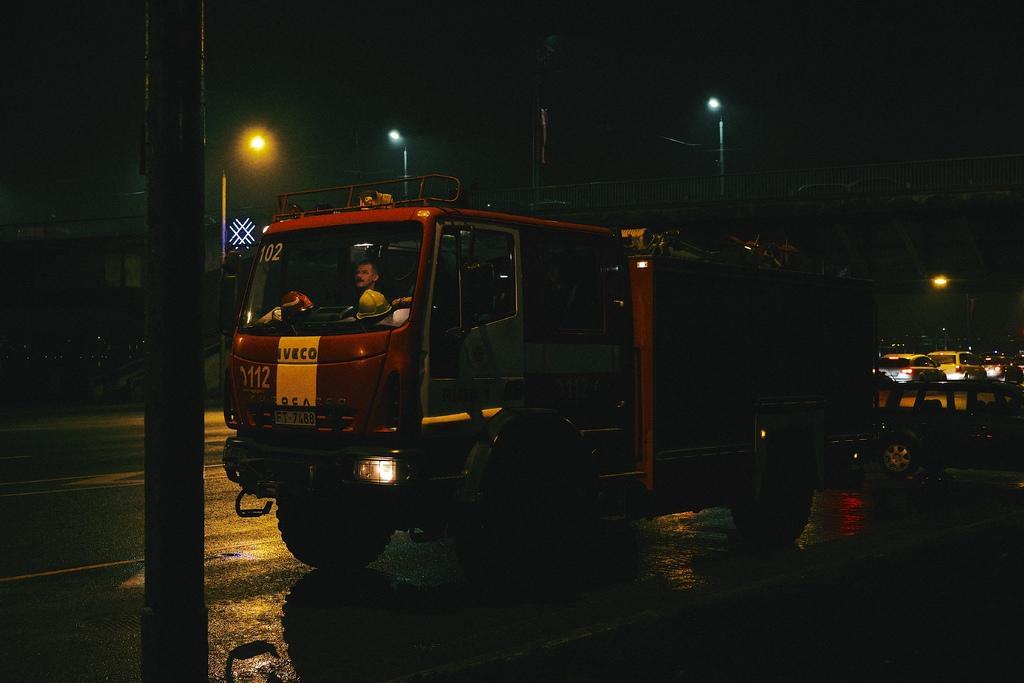In one or two sentences, can you explain what this image depicts? This picture is clicked outside. In the center we can see a person driving a truck and we can see a pole. In the background we can see the sky, lamp posts, bridge and the vehicles and some other items. 